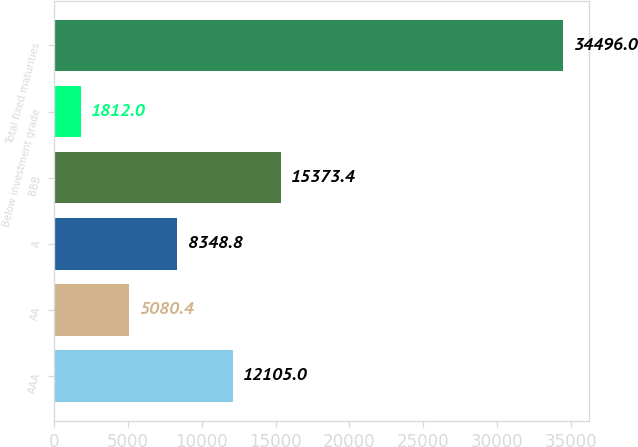<chart> <loc_0><loc_0><loc_500><loc_500><bar_chart><fcel>AAA<fcel>AA<fcel>A<fcel>BBB<fcel>Below investment grade<fcel>Total fixed maturities<nl><fcel>12105<fcel>5080.4<fcel>8348.8<fcel>15373.4<fcel>1812<fcel>34496<nl></chart> 